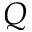Convert formula to latex. <formula><loc_0><loc_0><loc_500><loc_500>Q</formula> 